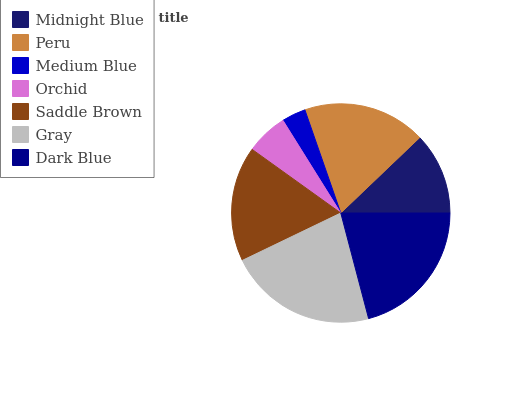Is Medium Blue the minimum?
Answer yes or no. Yes. Is Gray the maximum?
Answer yes or no. Yes. Is Peru the minimum?
Answer yes or no. No. Is Peru the maximum?
Answer yes or no. No. Is Peru greater than Midnight Blue?
Answer yes or no. Yes. Is Midnight Blue less than Peru?
Answer yes or no. Yes. Is Midnight Blue greater than Peru?
Answer yes or no. No. Is Peru less than Midnight Blue?
Answer yes or no. No. Is Saddle Brown the high median?
Answer yes or no. Yes. Is Saddle Brown the low median?
Answer yes or no. Yes. Is Midnight Blue the high median?
Answer yes or no. No. Is Gray the low median?
Answer yes or no. No. 